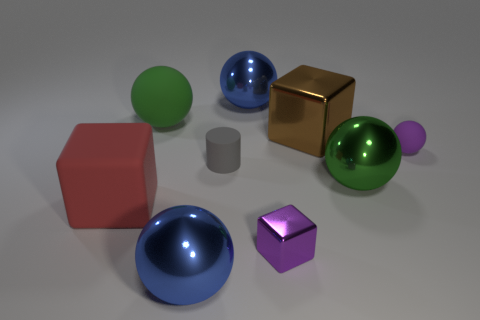Subtract all cyan blocks. Subtract all purple balls. How many blocks are left? 3 Add 1 rubber cylinders. How many objects exist? 10 Subtract all cylinders. How many objects are left? 8 Subtract 0 green cylinders. How many objects are left? 9 Subtract all small balls. Subtract all big matte spheres. How many objects are left? 7 Add 5 small matte balls. How many small matte balls are left? 6 Add 2 big shiny cubes. How many big shiny cubes exist? 3 